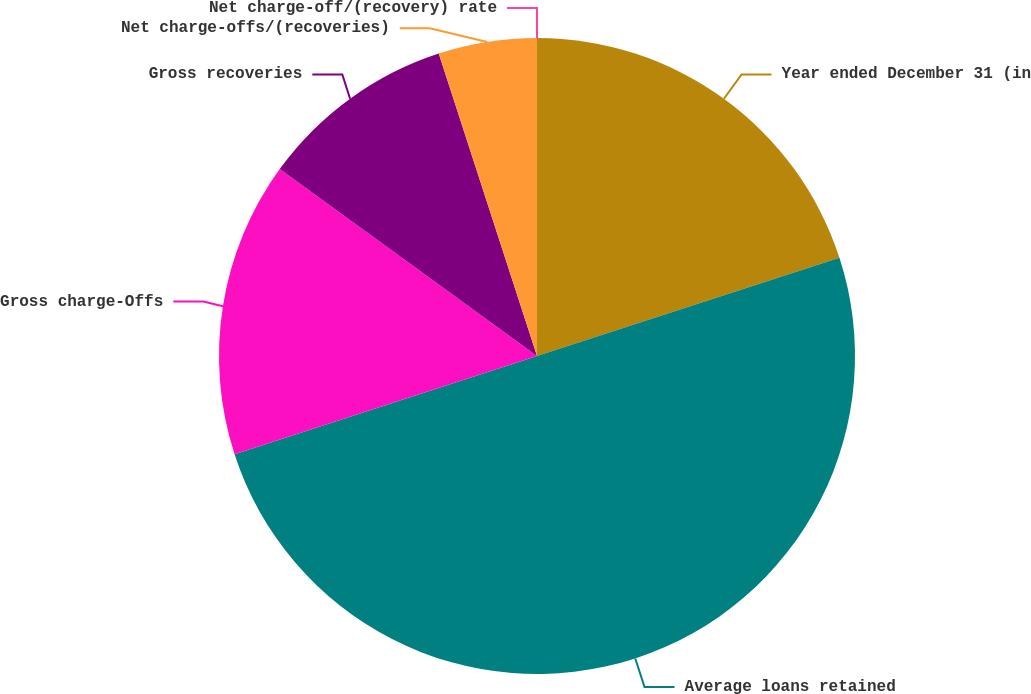Convert chart. <chart><loc_0><loc_0><loc_500><loc_500><pie_chart><fcel>Year ended December 31 (in<fcel>Average loans retained<fcel>Gross charge-Offs<fcel>Gross recoveries<fcel>Net charge-offs/(recoveries)<fcel>Net charge-off/(recovery) rate<nl><fcel>20.0%<fcel>50.0%<fcel>15.0%<fcel>10.0%<fcel>5.0%<fcel>0.0%<nl></chart> 